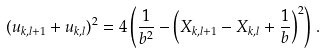<formula> <loc_0><loc_0><loc_500><loc_500>( u _ { k , l + 1 } + u _ { k , l } ) ^ { 2 } = 4 \left ( \frac { 1 } { b ^ { 2 } } - \left ( X _ { k , l + 1 } - X _ { k , l } + \frac { 1 } { b } \right ) ^ { 2 } \right ) \, .</formula> 